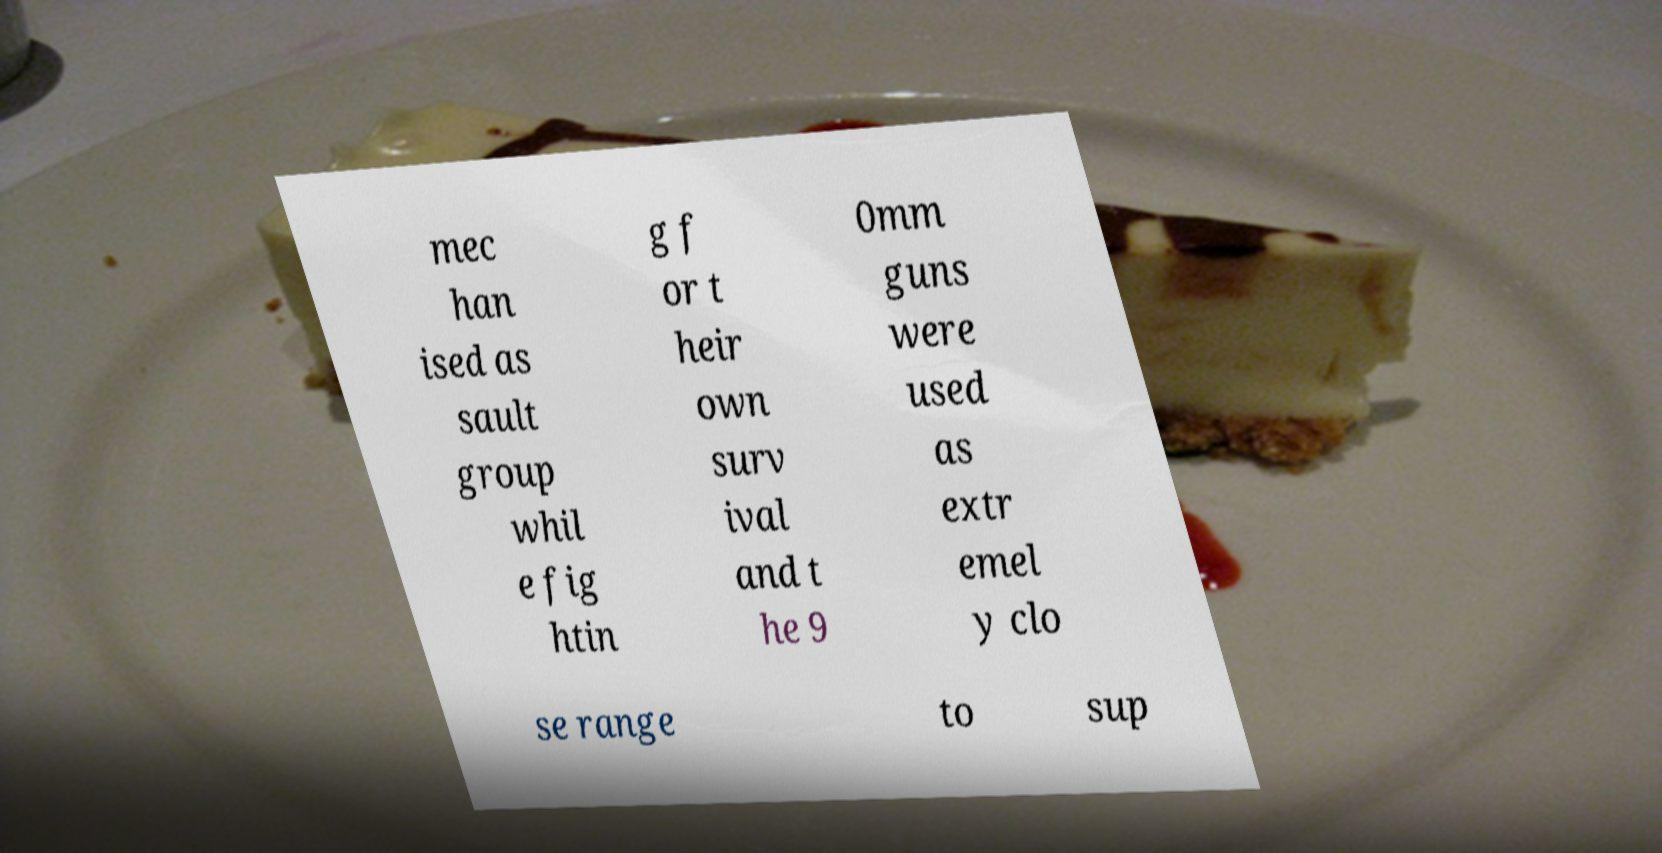For documentation purposes, I need the text within this image transcribed. Could you provide that? mec han ised as sault group whil e fig htin g f or t heir own surv ival and t he 9 0mm guns were used as extr emel y clo se range to sup 